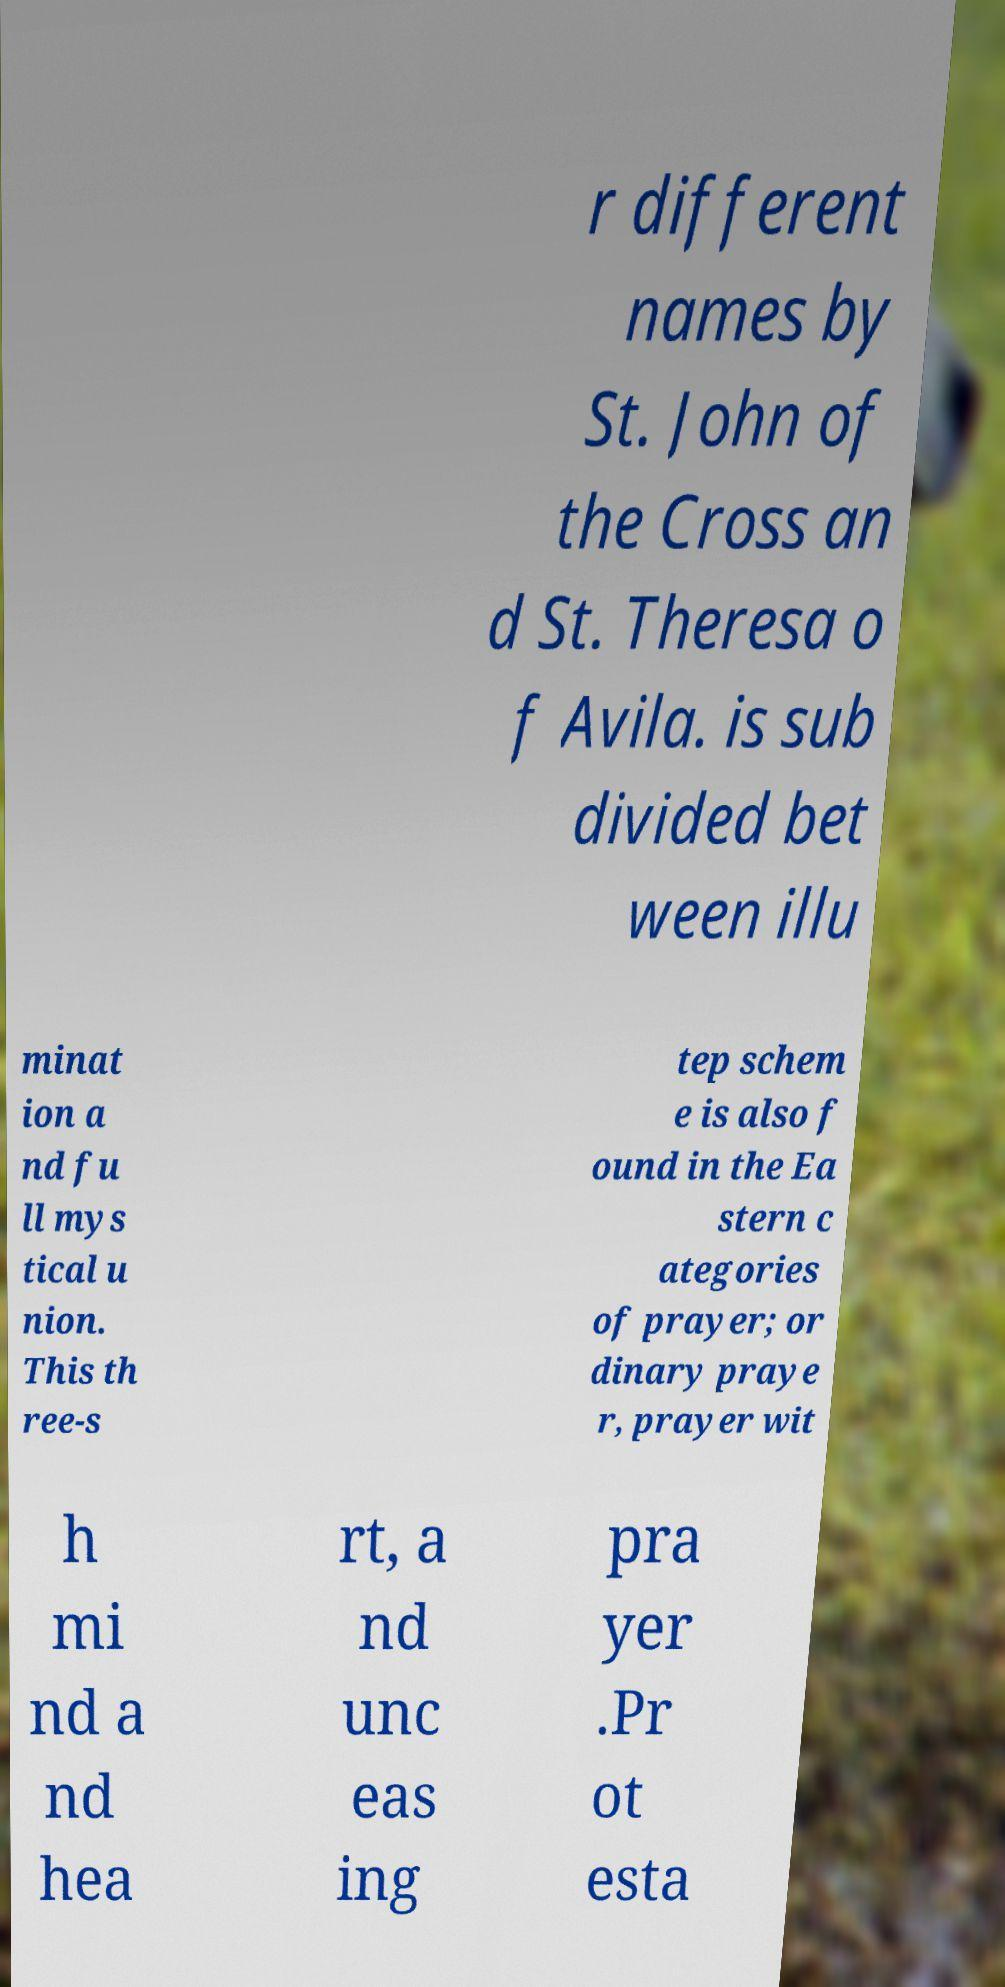Could you extract and type out the text from this image? r different names by St. John of the Cross an d St. Theresa o f Avila. is sub divided bet ween illu minat ion a nd fu ll mys tical u nion. This th ree-s tep schem e is also f ound in the Ea stern c ategories of prayer; or dinary praye r, prayer wit h mi nd a nd hea rt, a nd unc eas ing pra yer .Pr ot esta 